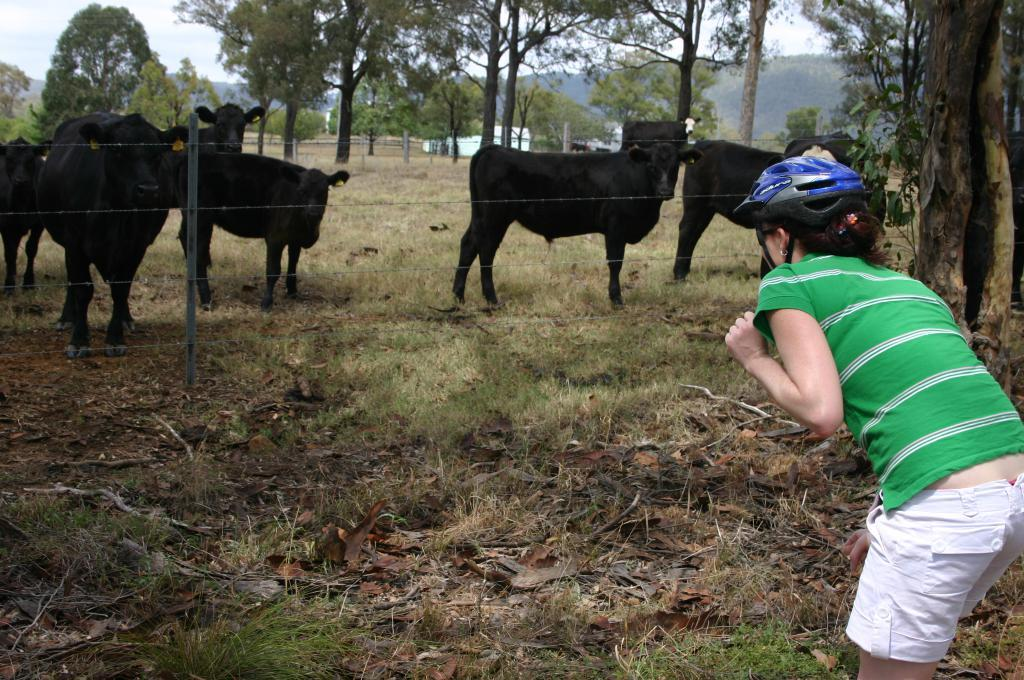What animals are present in the image? There are many buffaloes in the image. What type of vegetation is at the bottom of the image? There is green grass at the bottom of the image. Can you describe the woman's attire in the image? The woman is wearing a blue helmet in the image. What can be seen in the background of the image? There are trees in the background of the image. What type of horn is being played at the buffalo's birthday party in the image? There is no horn or birthday party depicted in the image; it features many buffaloes, green grass, a woman wearing a blue helmet, and trees in the background. 